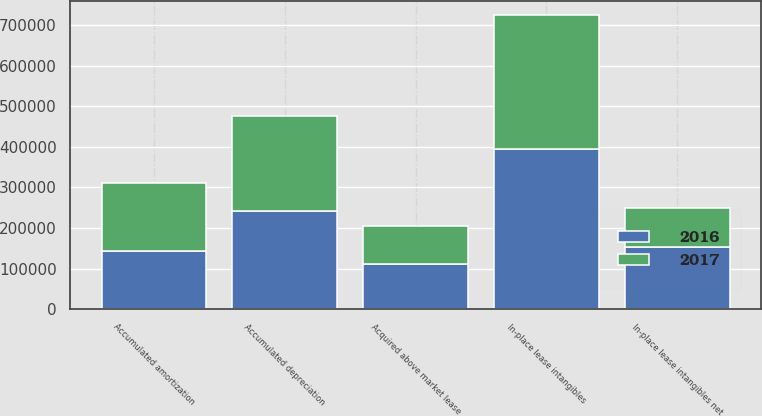<chart> <loc_0><loc_0><loc_500><loc_500><stacked_bar_chart><ecel><fcel>In-place lease intangibles<fcel>Accumulated depreciation<fcel>In-place lease intangibles net<fcel>Acquired above market lease<fcel>Accumulated amortization<nl><fcel>2017<fcel>328811<fcel>232757<fcel>96054<fcel>92405<fcel>167993<nl><fcel>2016<fcel>395713<fcel>242698<fcel>153015<fcel>112024<fcel>142557<nl></chart> 